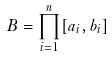<formula> <loc_0><loc_0><loc_500><loc_500>B = \prod _ { i = 1 } ^ { n } [ a _ { i } , b _ { i } ]</formula> 